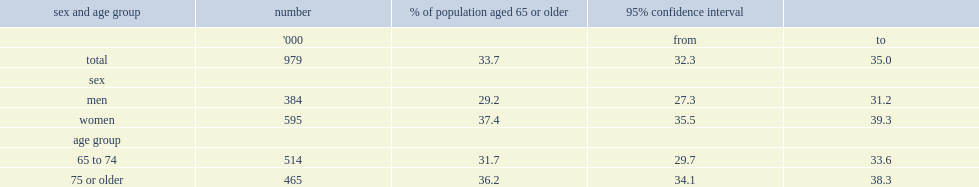How many canadian aged 65 or older were at nutritional risk in 2008/2009? 979. Which sex was more likely to be at nutritional risk? Women. Which age group of people were more likely to be at nutritional risk, 75 or older or 65 to 74? 75 or older. 